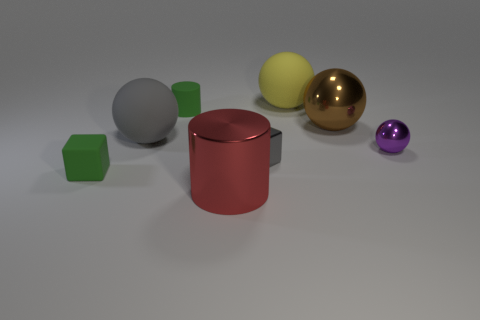Add 1 large blue cylinders. How many objects exist? 9 Subtract all blocks. How many objects are left? 6 Subtract 0 yellow cylinders. How many objects are left? 8 Subtract all purple metallic balls. Subtract all big spheres. How many objects are left? 4 Add 2 tiny matte cylinders. How many tiny matte cylinders are left? 3 Add 4 gray balls. How many gray balls exist? 5 